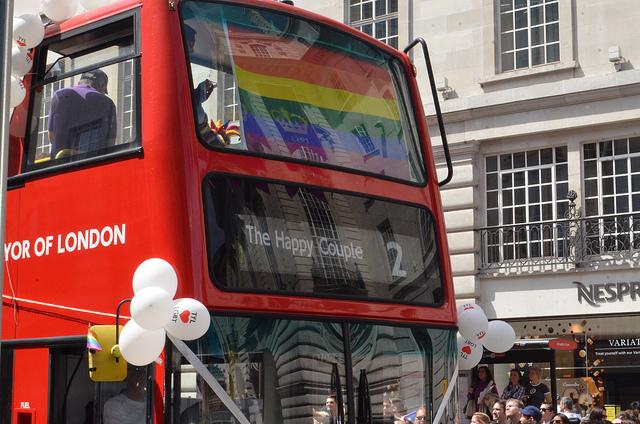How many stories tall is this bus?
Short answer required. 2. Does this bus support gay marriage?
Short answer required. Yes. What city name is on the bus?
Be succinct. London. 